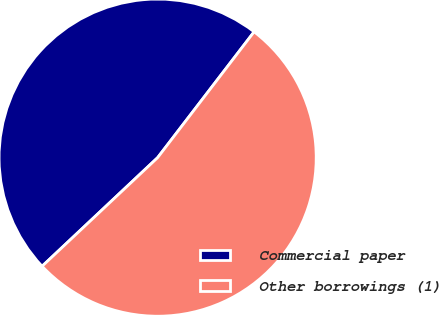Convert chart to OTSL. <chart><loc_0><loc_0><loc_500><loc_500><pie_chart><fcel>Commercial paper<fcel>Other borrowings (1)<nl><fcel>47.42%<fcel>52.58%<nl></chart> 